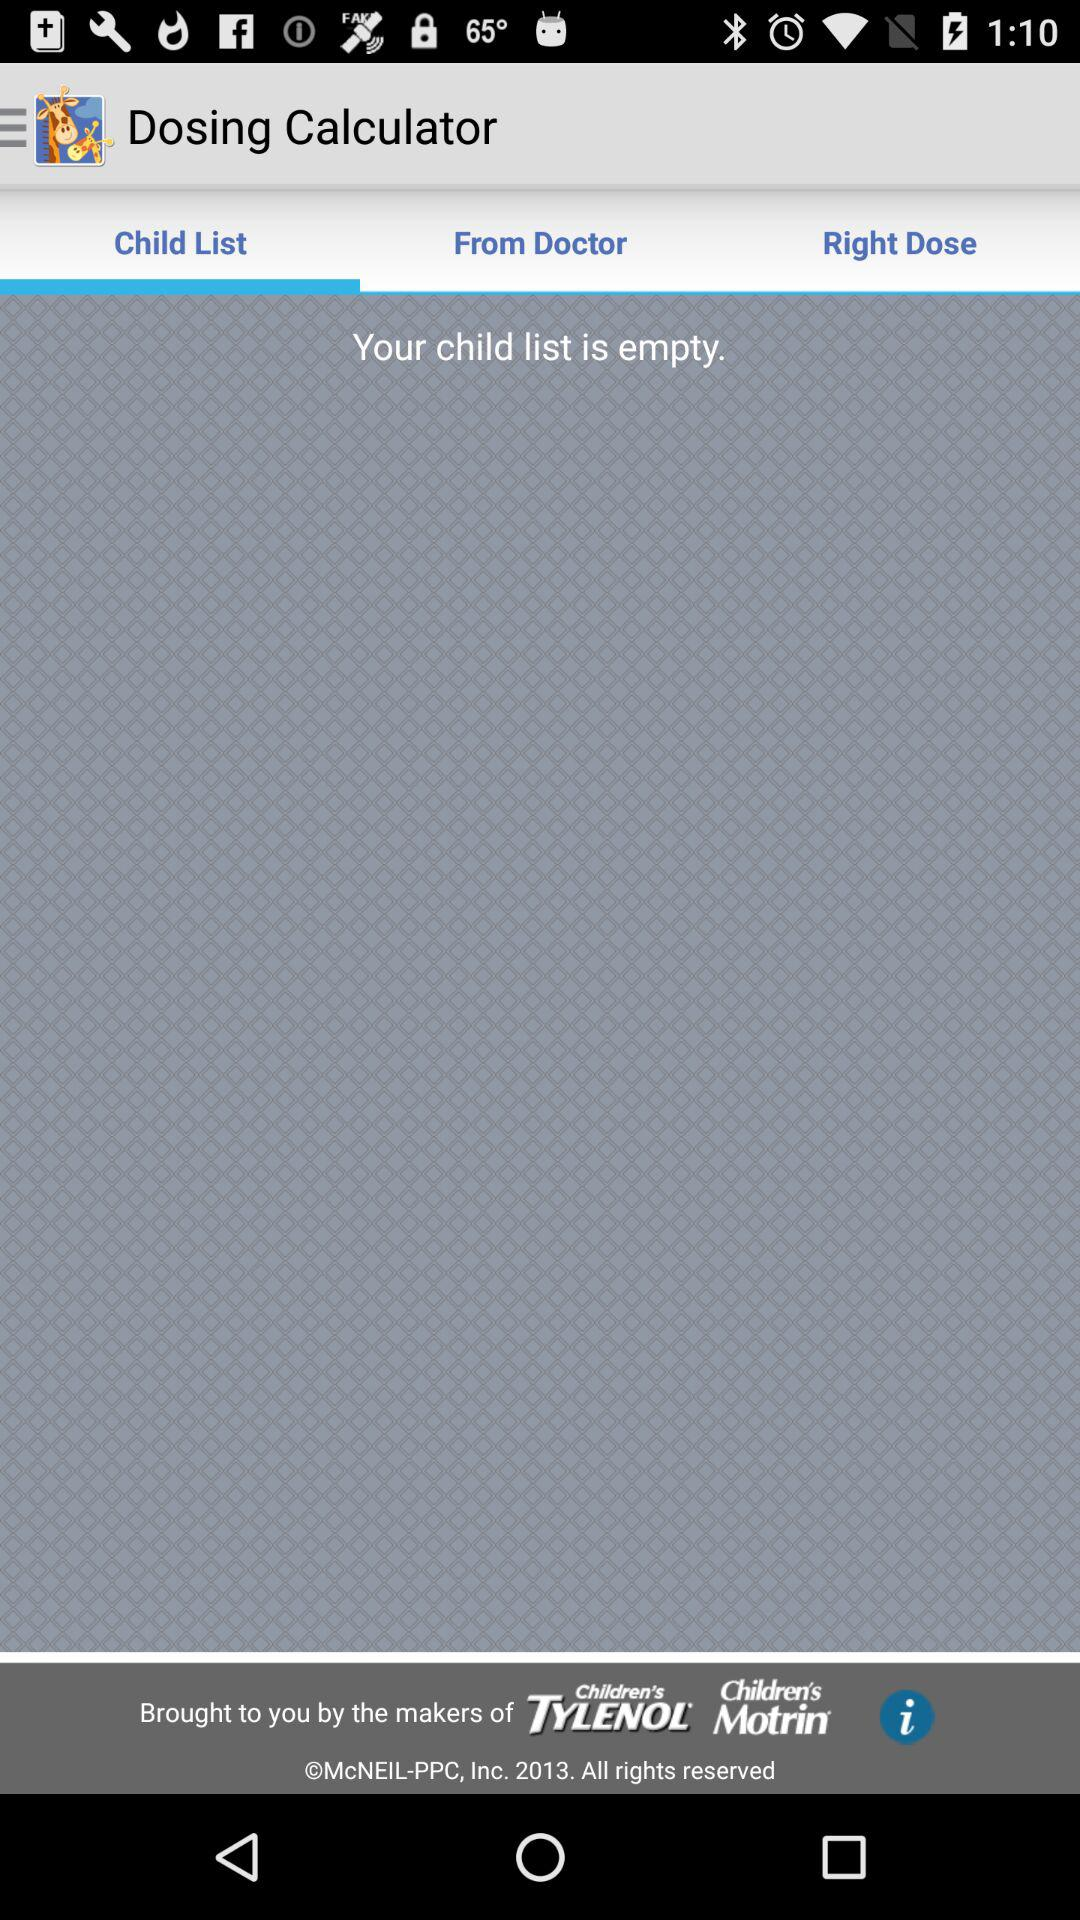Which option is selected in the "Dosing Calculator" application? The selected option is "Child List". 